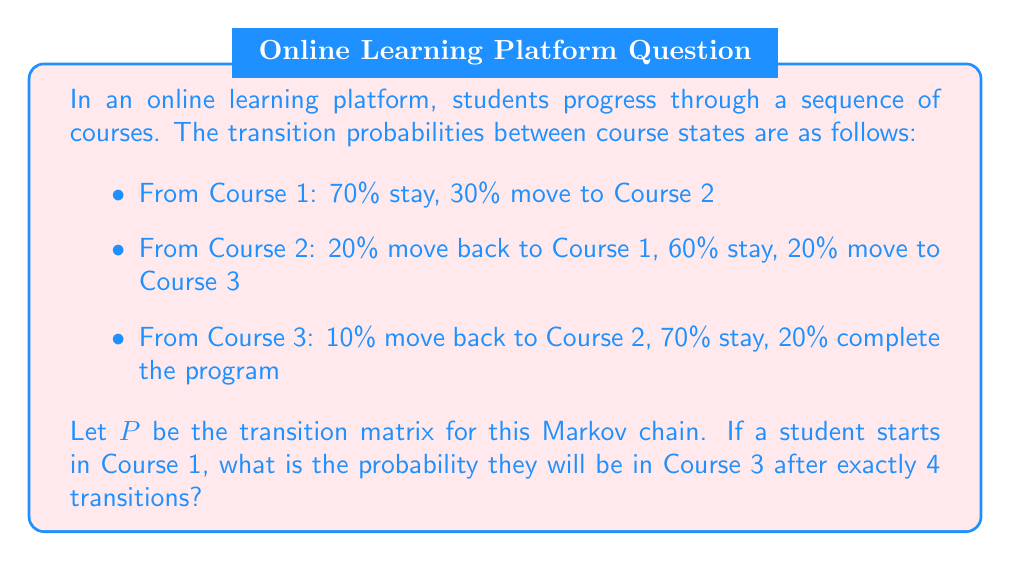Could you help me with this problem? To solve this problem, we'll follow these steps:

1) First, let's construct the transition matrix $P$ based on the given probabilities:

   $$P = \begin{bmatrix}
   0.7 & 0.3 & 0 & 0 \\
   0.2 & 0.6 & 0.2 & 0 \\
   0 & 0.1 & 0.7 & 0.2 \\
   0 & 0 & 0 & 1
   \end{bmatrix}$$

2) To find the probability of being in Course 3 after 4 transitions, we need to calculate $P^4$ and look at the entry in the first row, third column.

3) We can calculate $P^4$ using matrix multiplication:

   $$P^4 = P \times P \times P \times P$$

4) Using a computer algebra system or calculator to perform this multiplication, we get:

   $$P^4 \approx \begin{bmatrix}
   0.2401 & 0.3395 & 0.2807 & 0.1397 \\
   0.2296 & 0.3197 & 0.2959 & 0.1548 \\
   0.0922 & 0.1682 & 0.4151 & 0.3245 \\
   0 & 0 & 0 & 1
   \end{bmatrix}$$

5) The probability we're looking for is the entry in the first row, third column of $P^4$, which is approximately 0.2807 or 28.07%.

This result shows that after 4 transitions, there's about a 28.07% chance that a student who started in Course 1 will be in Course 3.
Answer: 0.2807 (or 28.07%) 